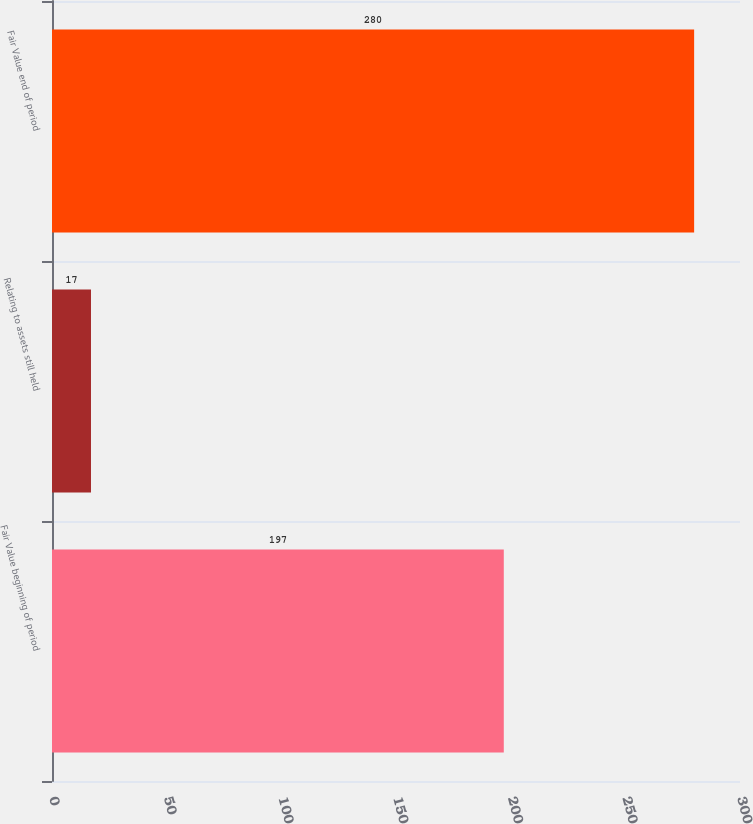<chart> <loc_0><loc_0><loc_500><loc_500><bar_chart><fcel>Fair Value beginning of period<fcel>Relating to assets still held<fcel>Fair Value end of period<nl><fcel>197<fcel>17<fcel>280<nl></chart> 